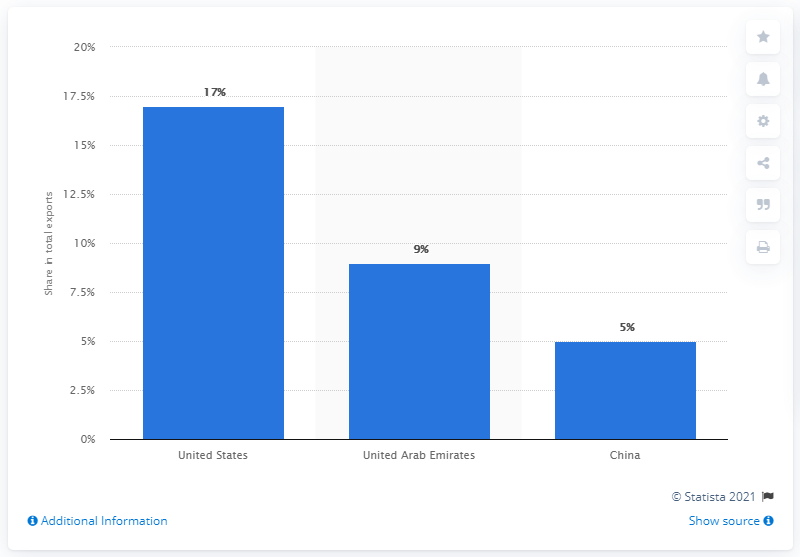Point out several critical features in this image. In 2019, India's main export partner was the United States. 